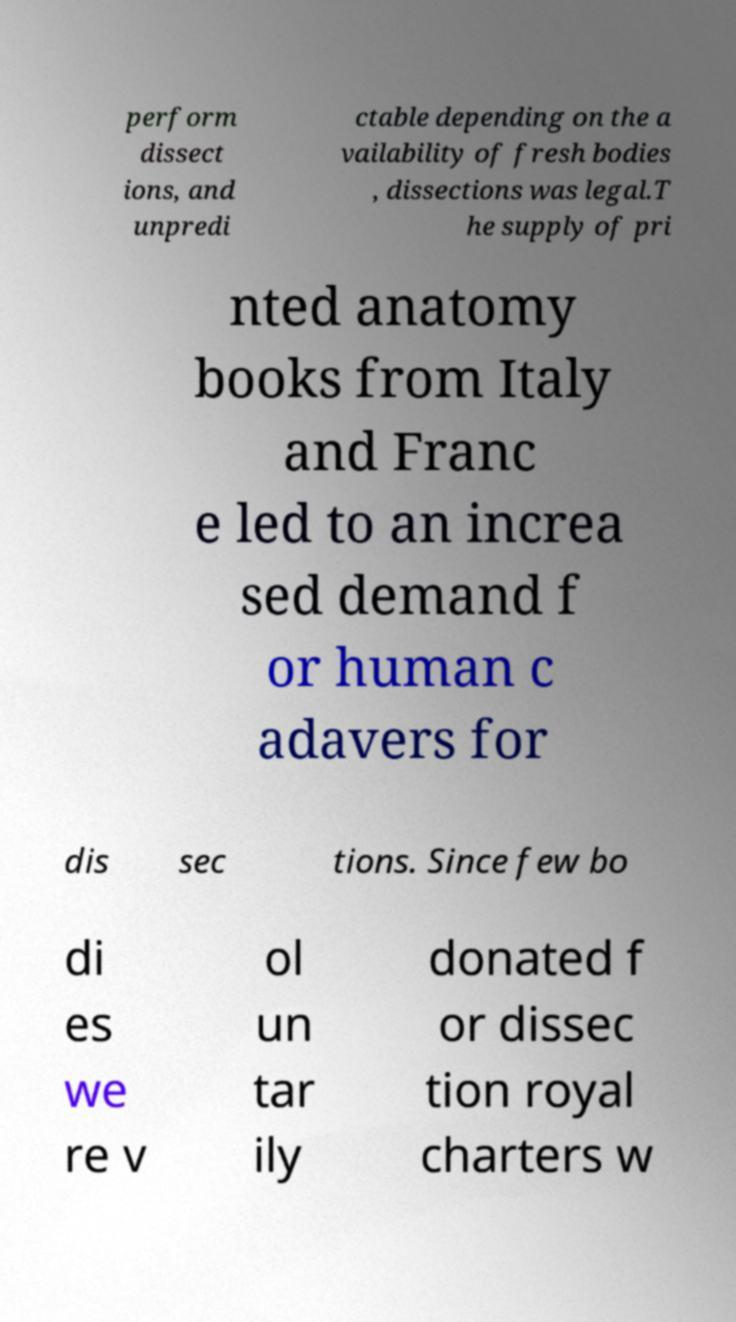Please read and relay the text visible in this image. What does it say? perform dissect ions, and unpredi ctable depending on the a vailability of fresh bodies , dissections was legal.T he supply of pri nted anatomy books from Italy and Franc e led to an increa sed demand f or human c adavers for dis sec tions. Since few bo di es we re v ol un tar ily donated f or dissec tion royal charters w 